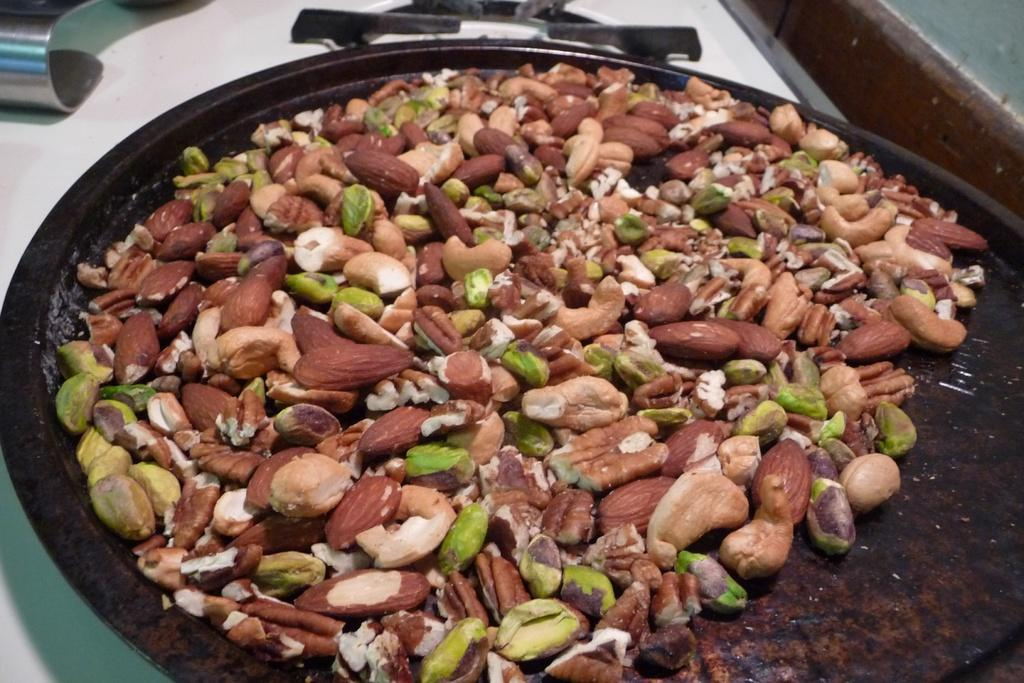What types of food items are present in the image? There are different types of nuts in the image. What type of flooring is visible in the image? There are white color tiles in the image. What type of toy is the governor playing with in the image? There is no toy or governor present in the image; it only features different types of nuts and white color tiles. 